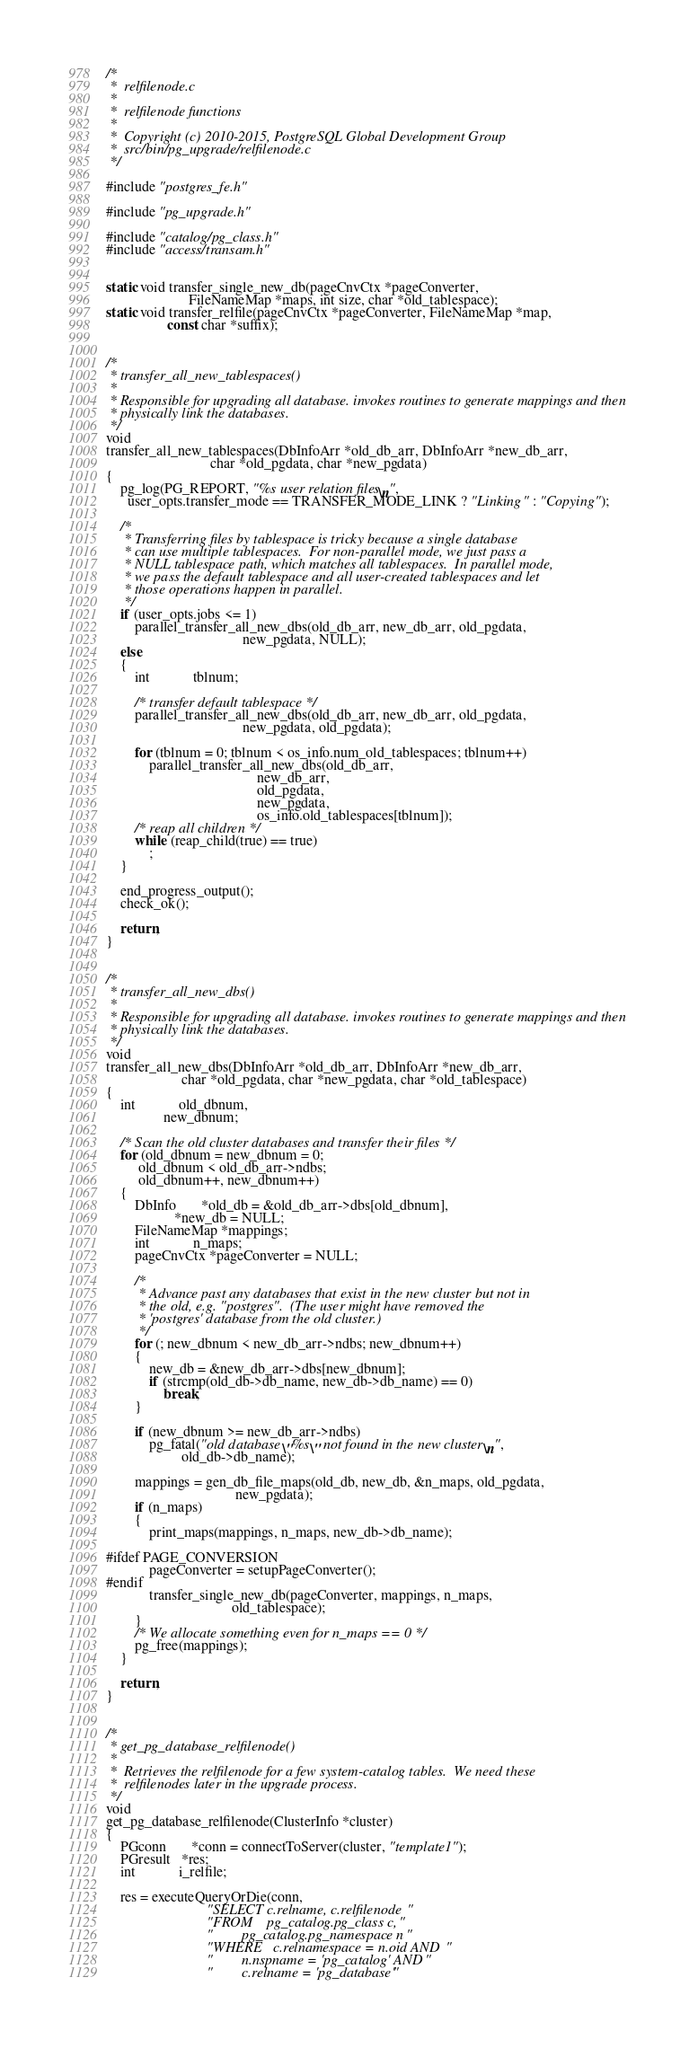Convert code to text. <code><loc_0><loc_0><loc_500><loc_500><_C_>/*
 *	relfilenode.c
 *
 *	relfilenode functions
 *
 *	Copyright (c) 2010-2015, PostgreSQL Global Development Group
 *	src/bin/pg_upgrade/relfilenode.c
 */

#include "postgres_fe.h"

#include "pg_upgrade.h"

#include "catalog/pg_class.h"
#include "access/transam.h"


static void transfer_single_new_db(pageCnvCtx *pageConverter,
					   FileNameMap *maps, int size, char *old_tablespace);
static void transfer_relfile(pageCnvCtx *pageConverter, FileNameMap *map,
				 const char *suffix);


/*
 * transfer_all_new_tablespaces()
 *
 * Responsible for upgrading all database. invokes routines to generate mappings and then
 * physically link the databases.
 */
void
transfer_all_new_tablespaces(DbInfoArr *old_db_arr, DbInfoArr *new_db_arr,
							 char *old_pgdata, char *new_pgdata)
{
	pg_log(PG_REPORT, "%s user relation files\n",
	  user_opts.transfer_mode == TRANSFER_MODE_LINK ? "Linking" : "Copying");

	/*
	 * Transferring files by tablespace is tricky because a single database
	 * can use multiple tablespaces.  For non-parallel mode, we just pass a
	 * NULL tablespace path, which matches all tablespaces.  In parallel mode,
	 * we pass the default tablespace and all user-created tablespaces and let
	 * those operations happen in parallel.
	 */
	if (user_opts.jobs <= 1)
		parallel_transfer_all_new_dbs(old_db_arr, new_db_arr, old_pgdata,
									  new_pgdata, NULL);
	else
	{
		int			tblnum;

		/* transfer default tablespace */
		parallel_transfer_all_new_dbs(old_db_arr, new_db_arr, old_pgdata,
									  new_pgdata, old_pgdata);

		for (tblnum = 0; tblnum < os_info.num_old_tablespaces; tblnum++)
			parallel_transfer_all_new_dbs(old_db_arr,
										  new_db_arr,
										  old_pgdata,
										  new_pgdata,
										  os_info.old_tablespaces[tblnum]);
		/* reap all children */
		while (reap_child(true) == true)
			;
	}

	end_progress_output();
	check_ok();

	return;
}


/*
 * transfer_all_new_dbs()
 *
 * Responsible for upgrading all database. invokes routines to generate mappings and then
 * physically link the databases.
 */
void
transfer_all_new_dbs(DbInfoArr *old_db_arr, DbInfoArr *new_db_arr,
					 char *old_pgdata, char *new_pgdata, char *old_tablespace)
{
	int			old_dbnum,
				new_dbnum;

	/* Scan the old cluster databases and transfer their files */
	for (old_dbnum = new_dbnum = 0;
		 old_dbnum < old_db_arr->ndbs;
		 old_dbnum++, new_dbnum++)
	{
		DbInfo	   *old_db = &old_db_arr->dbs[old_dbnum],
				   *new_db = NULL;
		FileNameMap *mappings;
		int			n_maps;
		pageCnvCtx *pageConverter = NULL;

		/*
		 * Advance past any databases that exist in the new cluster but not in
		 * the old, e.g. "postgres".  (The user might have removed the
		 * 'postgres' database from the old cluster.)
		 */
		for (; new_dbnum < new_db_arr->ndbs; new_dbnum++)
		{
			new_db = &new_db_arr->dbs[new_dbnum];
			if (strcmp(old_db->db_name, new_db->db_name) == 0)
				break;
		}

		if (new_dbnum >= new_db_arr->ndbs)
			pg_fatal("old database \"%s\" not found in the new cluster\n",
					 old_db->db_name);

		mappings = gen_db_file_maps(old_db, new_db, &n_maps, old_pgdata,
									new_pgdata);
		if (n_maps)
		{
			print_maps(mappings, n_maps, new_db->db_name);

#ifdef PAGE_CONVERSION
			pageConverter = setupPageConverter();
#endif
			transfer_single_new_db(pageConverter, mappings, n_maps,
								   old_tablespace);
		}
		/* We allocate something even for n_maps == 0 */
		pg_free(mappings);
	}

	return;
}


/*
 * get_pg_database_relfilenode()
 *
 *	Retrieves the relfilenode for a few system-catalog tables.  We need these
 *	relfilenodes later in the upgrade process.
 */
void
get_pg_database_relfilenode(ClusterInfo *cluster)
{
	PGconn	   *conn = connectToServer(cluster, "template1");
	PGresult   *res;
	int			i_relfile;

	res = executeQueryOrDie(conn,
							"SELECT c.relname, c.relfilenode "
							"FROM	pg_catalog.pg_class c, "
							"		pg_catalog.pg_namespace n "
							"WHERE	c.relnamespace = n.oid AND "
							"		n.nspname = 'pg_catalog' AND "
							"		c.relname = 'pg_database' "</code> 